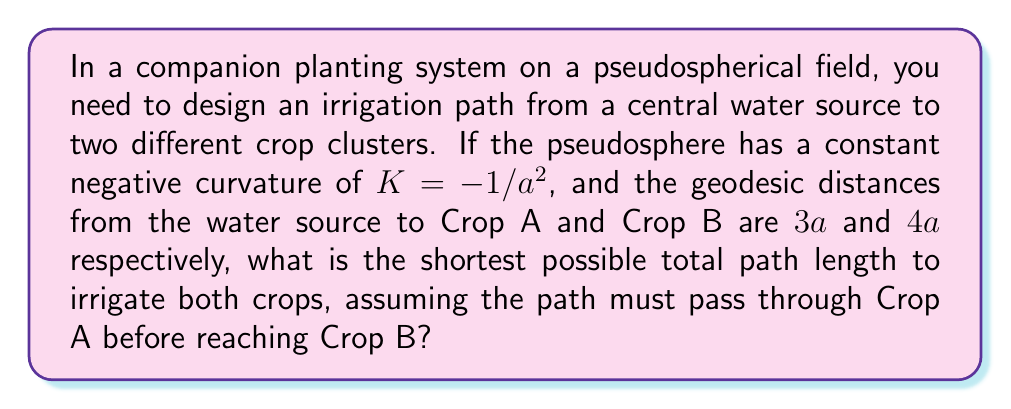Give your solution to this math problem. Let's approach this step-by-step:

1) On a pseudosphere, the shortest path between two points is a geodesic. The length of a geodesic between two points with distance $d$ on a pseudosphere with curvature $K = -1/a^2$ is given by:

   $$L = a \cdot \text{arcosh}(\cosh(d/a))$$

2) We're given that the distances to Crop A and from Crop A to Crop B are $3a$ and $4a$ respectively.

3) For the path to the first crop (Crop A):
   $$L_1 = a \cdot \text{arcosh}(\cosh(3a/a)) = a \cdot \text{arcosh}(\cosh(3))$$

4) For the path from Crop A to Crop B:
   $$L_2 = a \cdot \text{arcosh}(\cosh(4a/a)) = a \cdot \text{arcosh}(\cosh(4))$$

5) The total path length is the sum of these two segments:
   $$L_{total} = L_1 + L_2 = a \cdot [\text{arcosh}(\cosh(3)) + \text{arcosh}(\cosh(4))]$$

6) We can simplify this using the properties of hyperbolic functions:
   $$L_{total} = a \cdot [\text{arcosh}(4.7298) + \text{arcosh}(27.3082)]$$
   $$L_{total} = a \cdot [2.6339 + 4.0167]$$
   $$L_{total} = 6.6506a$$

Therefore, the shortest total path length to irrigate both crops is approximately $6.6506a$.
Answer: $6.6506a$ 